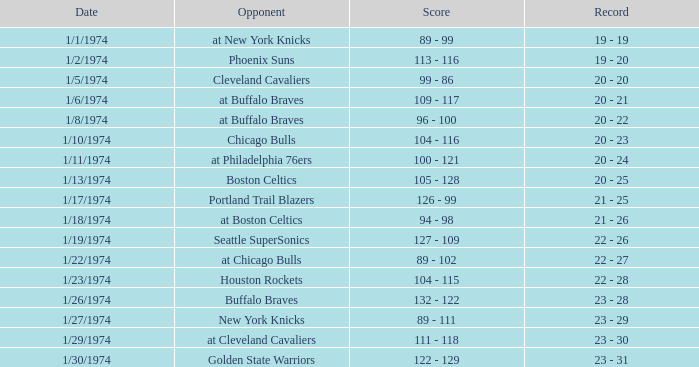On january 27, 1974, what was the outcome following the completion of the 51st game? 23 - 29. Would you be able to parse every entry in this table? {'header': ['Date', 'Opponent', 'Score', 'Record'], 'rows': [['1/1/1974', 'at New York Knicks', '89 - 99', '19 - 19'], ['1/2/1974', 'Phoenix Suns', '113 - 116', '19 - 20'], ['1/5/1974', 'Cleveland Cavaliers', '99 - 86', '20 - 20'], ['1/6/1974', 'at Buffalo Braves', '109 - 117', '20 - 21'], ['1/8/1974', 'at Buffalo Braves', '96 - 100', '20 - 22'], ['1/10/1974', 'Chicago Bulls', '104 - 116', '20 - 23'], ['1/11/1974', 'at Philadelphia 76ers', '100 - 121', '20 - 24'], ['1/13/1974', 'Boston Celtics', '105 - 128', '20 - 25'], ['1/17/1974', 'Portland Trail Blazers', '126 - 99', '21 - 25'], ['1/18/1974', 'at Boston Celtics', '94 - 98', '21 - 26'], ['1/19/1974', 'Seattle SuperSonics', '127 - 109', '22 - 26'], ['1/22/1974', 'at Chicago Bulls', '89 - 102', '22 - 27'], ['1/23/1974', 'Houston Rockets', '104 - 115', '22 - 28'], ['1/26/1974', 'Buffalo Braves', '132 - 122', '23 - 28'], ['1/27/1974', 'New York Knicks', '89 - 111', '23 - 29'], ['1/29/1974', 'at Cleveland Cavaliers', '111 - 118', '23 - 30'], ['1/30/1974', 'Golden State Warriors', '122 - 129', '23 - 31']]} 